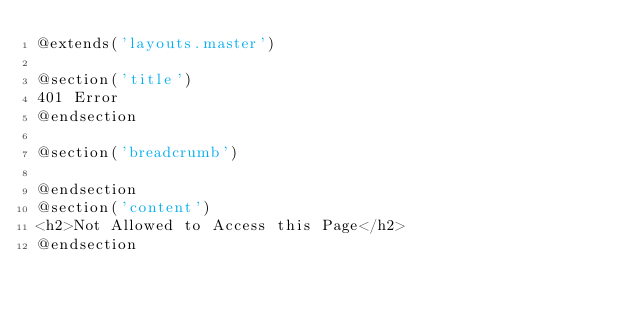<code> <loc_0><loc_0><loc_500><loc_500><_PHP_>@extends('layouts.master')

@section('title')
401 Error
@endsection

@section('breadcrumb')

@endsection
@section('content')
<h2>Not Allowed to Access this Page</h2>
@endsection
</code> 